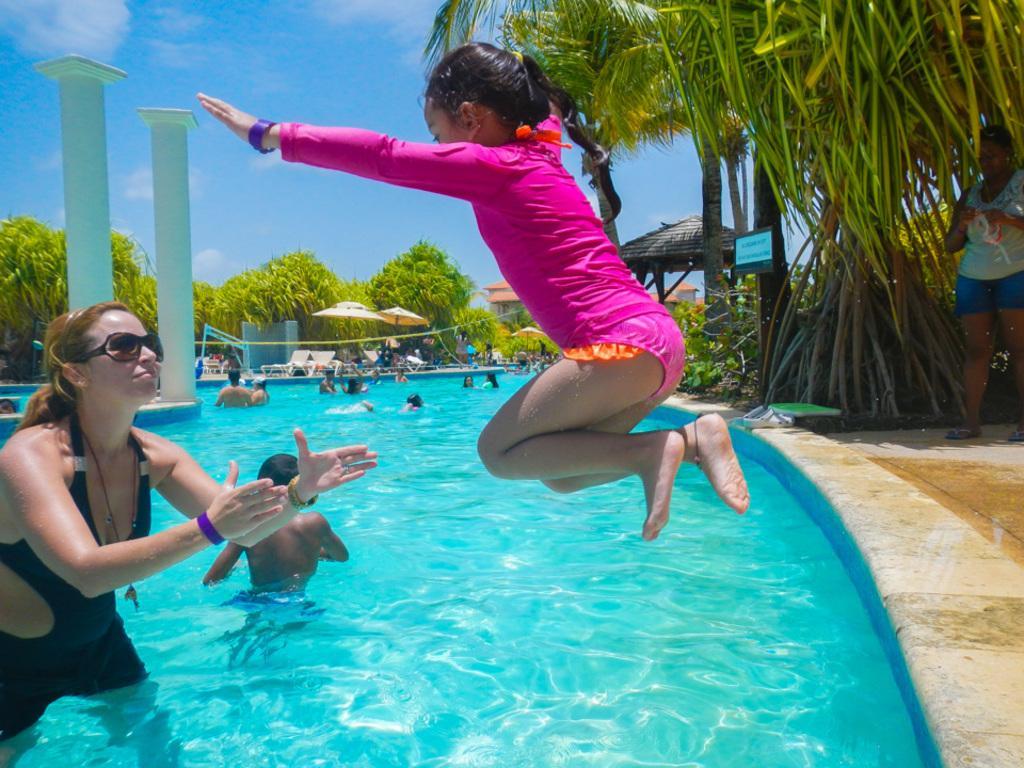Describe this image in one or two sentences. In this image I can see group of people, in front I can see two persons, one person is standing in the swimming pool and the other person is in air. The person is wearing pink dress, background I can see trees in green color and sky in blue and white color. 